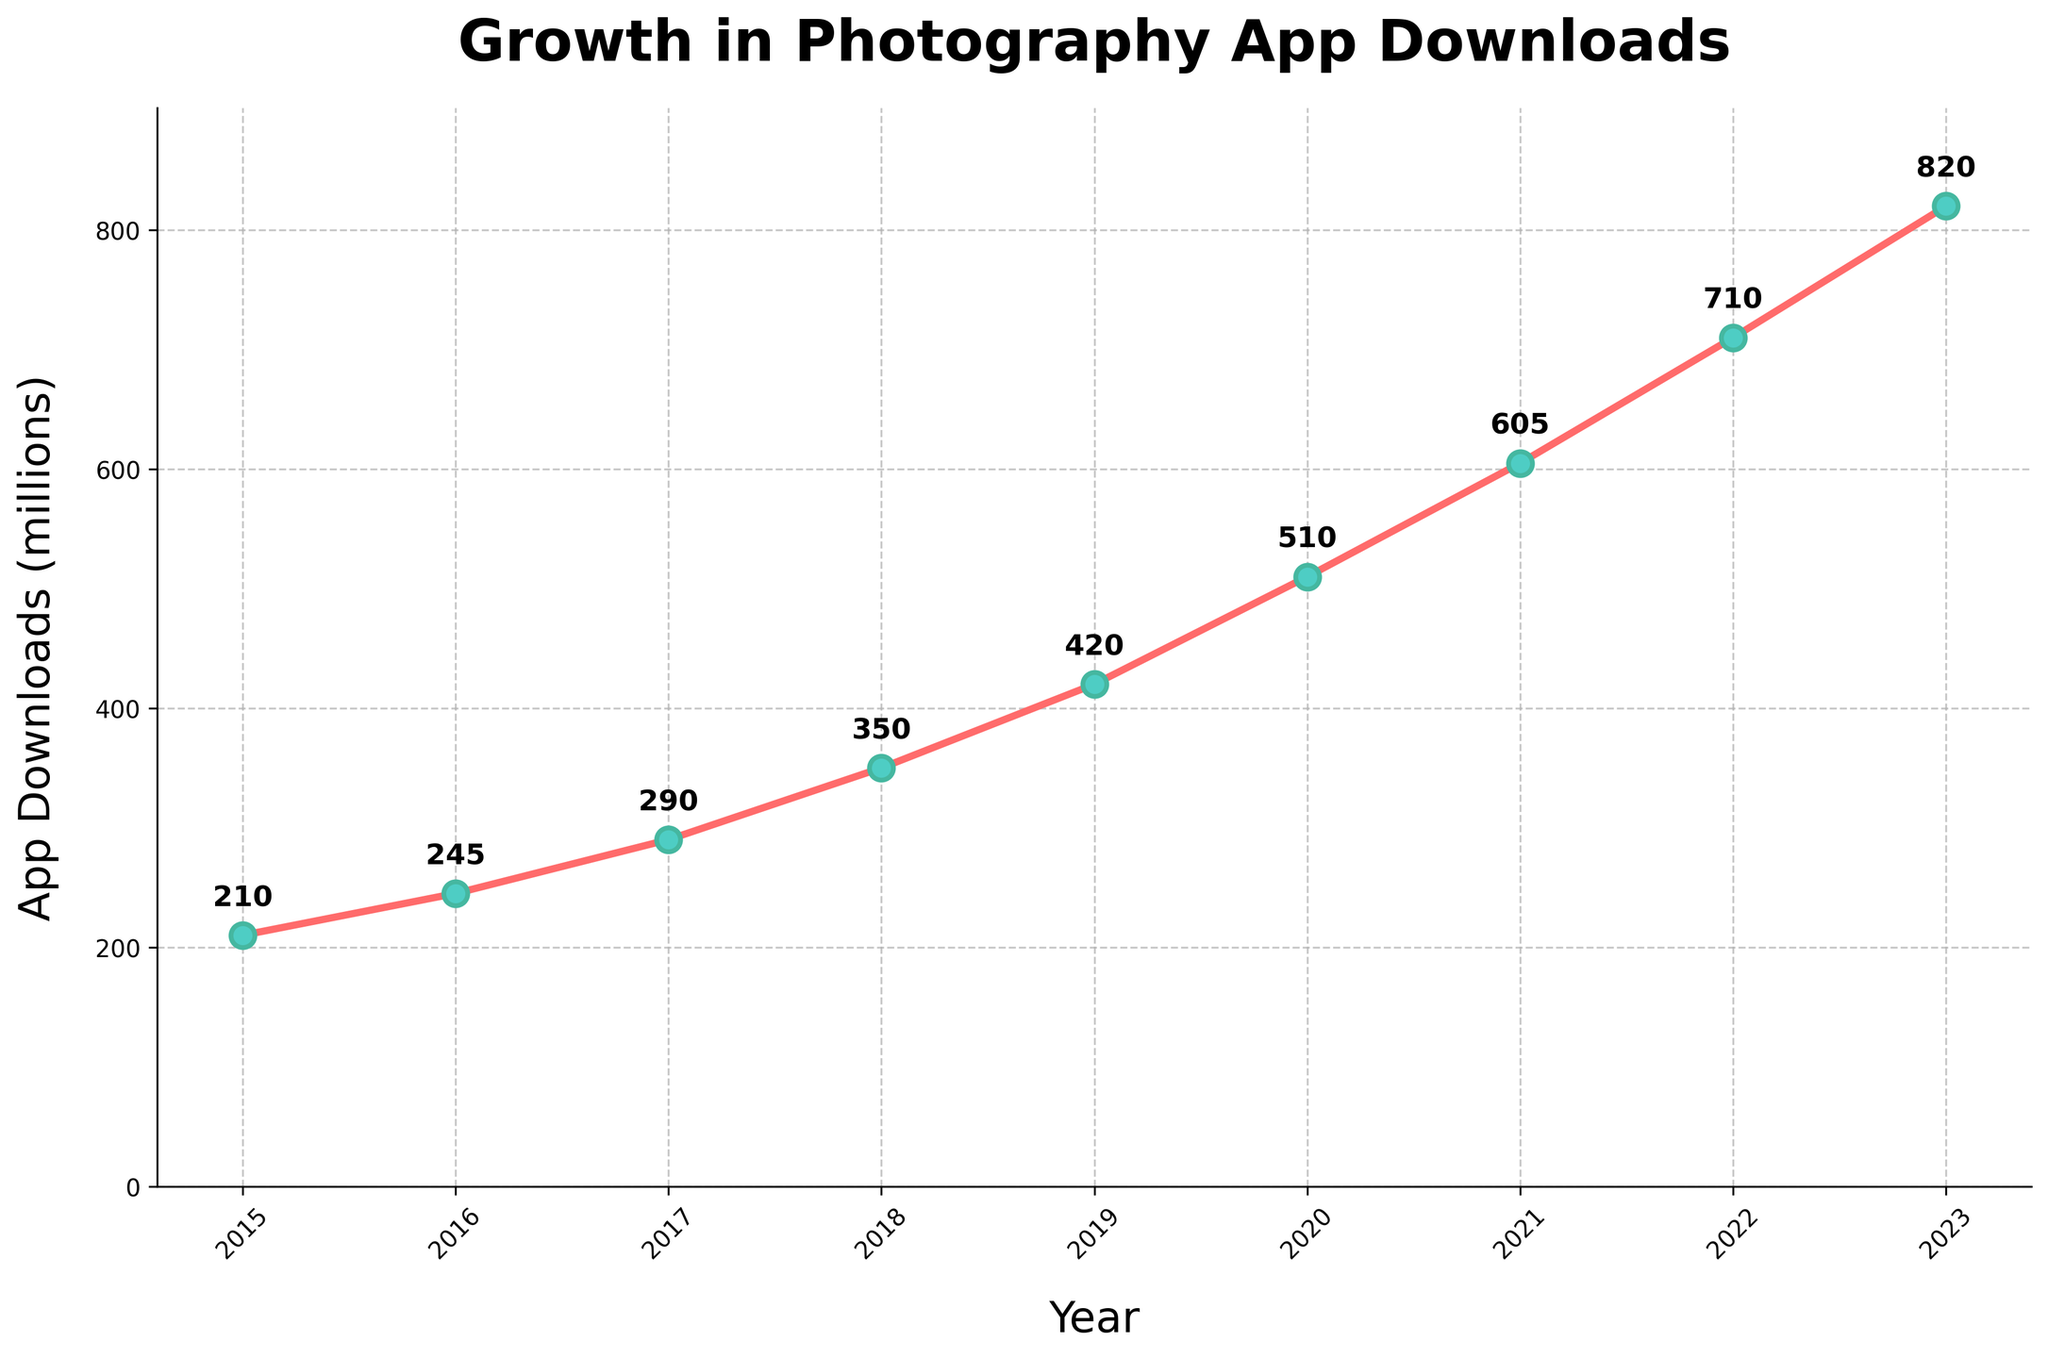Which year had the highest number of photography-app downloads? The chart shows that the year 2023 has the highest number of app downloads, marked by a notable peak at the year 2023.
Answer: 2023 By how many million downloads did the number of downloads increase from 2015 to 2023? The number of downloads in 2015 was 210 million, and in 2023, it was 820 million. The increase is calculated as 820 million - 210 million.
Answer: 610 million What was the average number of app downloads between 2015 and 2023? To find the average, sum all the app downloads from 2015 to 2023 (210 + 245 + 290 + 350 + 420 + 510 + 605 + 710 + 820) and divide by 9 (the number of years). The sum is 4160 million, so the average is 4160 million / 9.
Answer: 462.22 million Between which two consecutive years did the number of downloads increase the most? To find the years with the most significant increase, calculate the yearly differences and find the maximum difference. The differences are: 2016-2015: 35 million, 2017-2016: 45 million, 2018-2017: 60 million, 2019-2018: 70 million, 2020-2019: 90 million, 2021-2020: 95 million, 2022-2021: 105 million, 2023-2022: 110 million. The maximum increase is between 2022 and 2023.
Answer: 2022-2023 How much did the number of downloads change annually on average from 2015 to 2023? First, find the total change in downloads from 2015 to 2023, which is 820 million - 210 million = 610 million. Then, divide by the number of years (2023 - 2015 = 8 years). The average annual change is 610 million / 8.
Answer: 76.25 million Did the number of downloads ever decrease from one year to the next? By examining the trend line, we see that the number of downloads consistently increases each year without any decreases.
Answer: No Which year saw a higher number of downloads: 2018 or 2020? According to the graph, 2018 had 350 million downloads, and 2020 had 510 million downloads. 2020 had higher downloads.
Answer: 2020 What was the percentage increase in downloads from 2019 to 2020? To calculate the percentage increase: ((510 million - 420 million) / 420 million) * 100%. The increase from 420 to 510 is 90 million, so the calculation is (90 million / 420 million) * 100%.
Answer: 21.43% What is the trend in the number of app downloads from 2015 to 2023? The trend shows a significant year-over-year increase in app downloads, with the growth rate accelerating towards the later years, as seen by the steeper slope of the line after 2018.
Answer: Increasing 